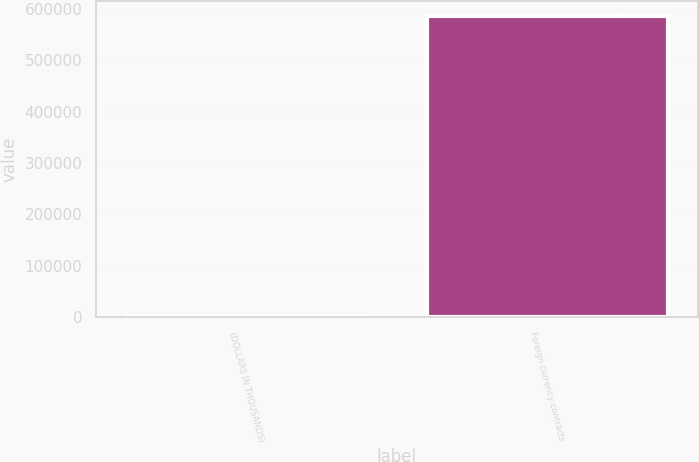Convert chart to OTSL. <chart><loc_0><loc_0><loc_500><loc_500><bar_chart><fcel>(DOLLARS IN THOUSANDS)<fcel>Foreign currency contracts<nl><fcel>2018<fcel>585581<nl></chart> 